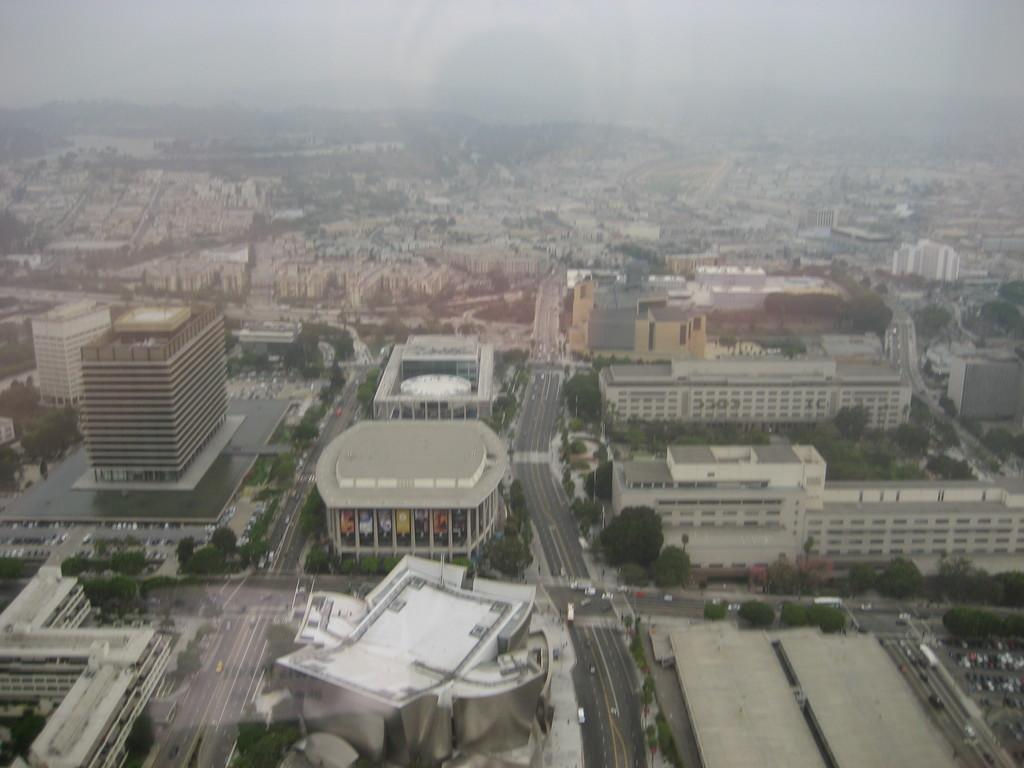What type of view is shown in the image? The image is an aerial view of a city. What structures can be seen in the image? There are buildings visible in the image. What else can be seen in the image besides buildings? Roads and trees are visible in the image. What is visible at the top of the image? The sky is visible at the top of the image. What day of the week is depicted in the image? The image does not depict a specific day of the week; it is a static aerial view of a city. 